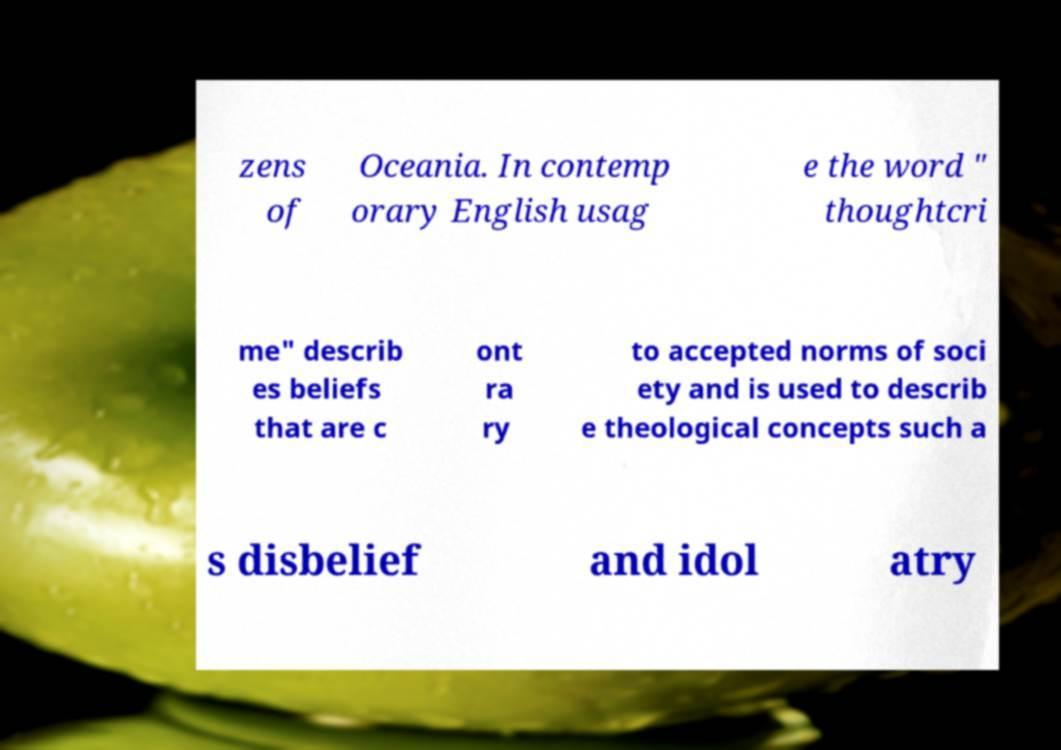For documentation purposes, I need the text within this image transcribed. Could you provide that? zens of Oceania. In contemp orary English usag e the word " thoughtcri me" describ es beliefs that are c ont ra ry to accepted norms of soci ety and is used to describ e theological concepts such a s disbelief and idol atry 